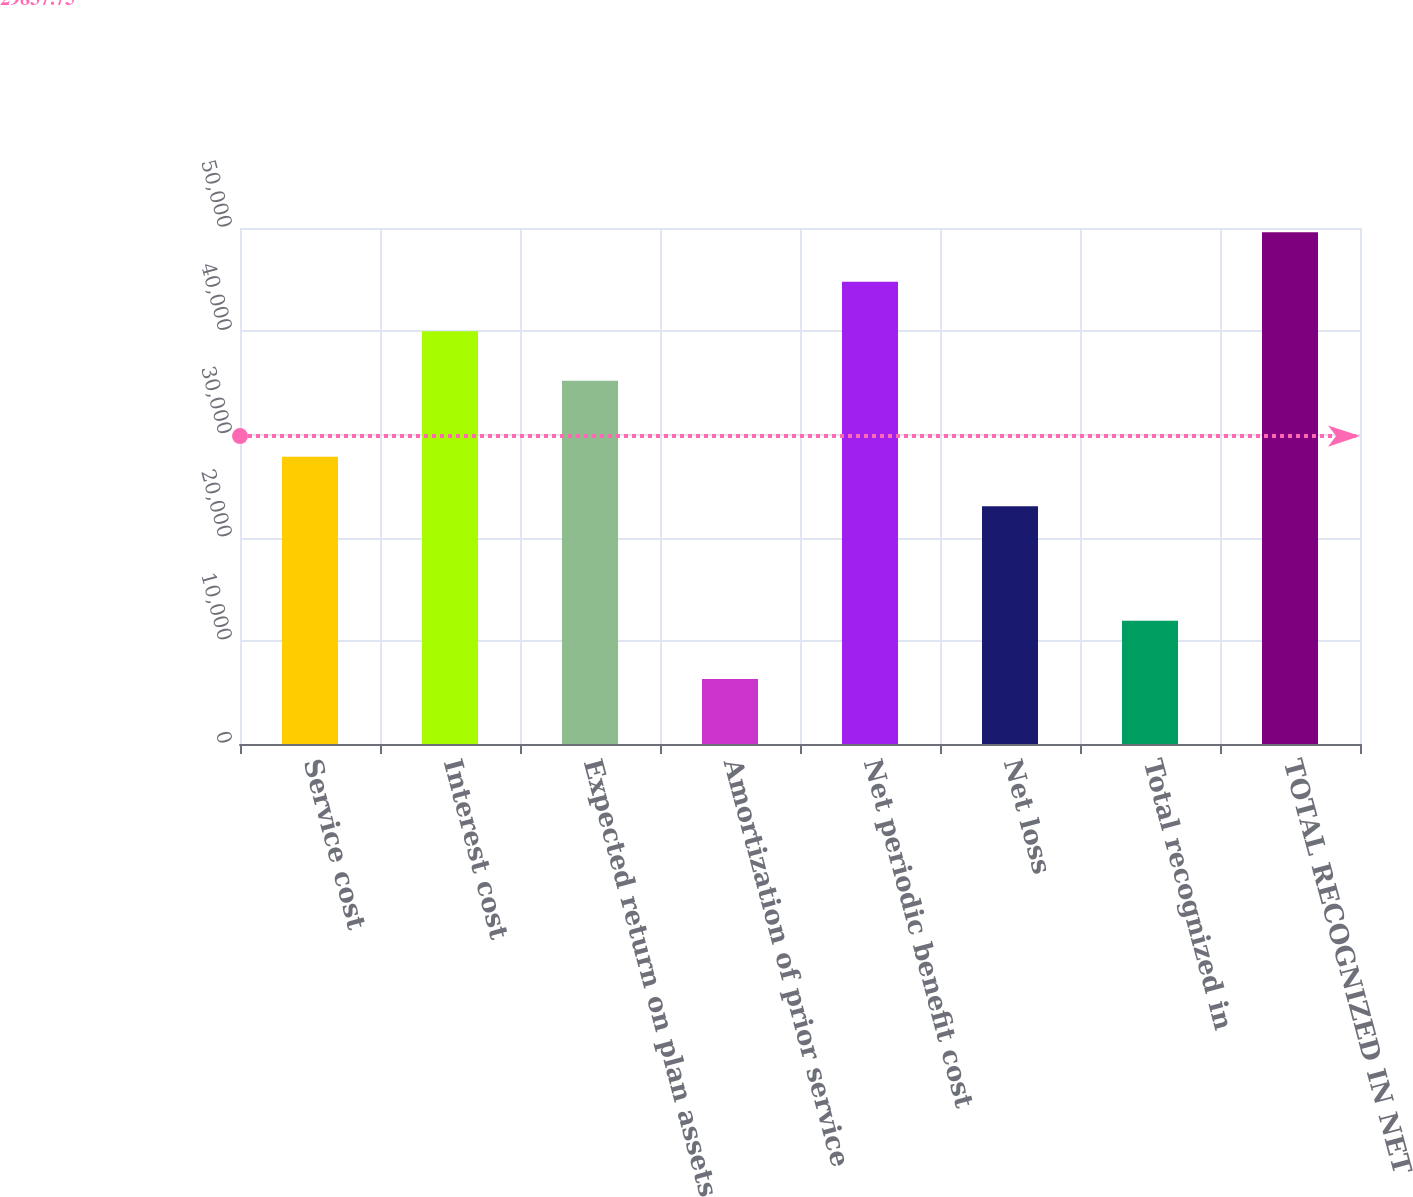Convert chart to OTSL. <chart><loc_0><loc_0><loc_500><loc_500><bar_chart><fcel>Service cost<fcel>Interest cost<fcel>Expected return on plan assets<fcel>Amortization of prior service<fcel>Net periodic benefit cost<fcel>Net loss<fcel>Total recognized in<fcel>TOTAL RECOGNIZED IN NET<nl><fcel>27838.5<fcel>39997.5<fcel>35207<fcel>6296.5<fcel>44788<fcel>23048<fcel>11948<fcel>49578.5<nl></chart> 